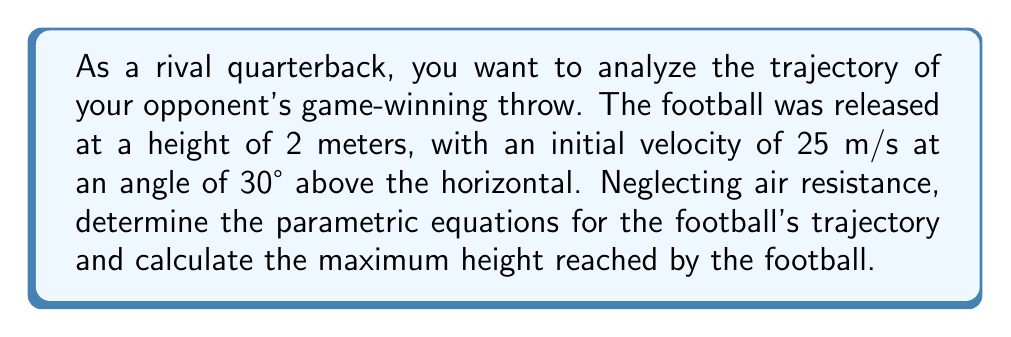Help me with this question. Let's approach this step-by-step:

1) First, we need to set up our parametric equations. In general, for a projectile motion, we have:

   $x(t) = x_0 + v_0 \cos(\theta) t$
   $y(t) = y_0 + v_0 \sin(\theta) t - \frac{1}{2}gt^2$

   Where:
   - $(x_0, y_0)$ is the initial position
   - $v_0$ is the initial velocity
   - $\theta$ is the angle of launch
   - $g$ is the acceleration due to gravity (9.8 m/s²)
   - $t$ is time

2) Given information:
   - $x_0 = 0$ (we can assume the initial horizontal position is 0)
   - $y_0 = 2$ meters
   - $v_0 = 25$ m/s
   - $\theta = 30°$

3) Let's substitute these values:

   $x(t) = 0 + 25 \cos(30°) t = 25 \cos(30°) t$
   $y(t) = 2 + 25 \sin(30°) t - \frac{1}{2}(9.8)t^2$

4) Simplify:
   $x(t) = 25 \cdot \frac{\sqrt{3}}{2} t \approx 21.65t$
   $y(t) = 2 + 25 \cdot \frac{1}{2} t - 4.9t^2 = 2 + 12.5t - 4.9t^2$

5) To find the maximum height, we need to find when the vertical velocity is zero:
   $\frac{dy}{dt} = 12.5 - 9.8t = 0$
   $t = \frac{12.5}{9.8} \approx 1.28$ seconds

6) Substitute this time back into the y(t) equation:
   $y_{max} = 2 + 12.5(1.28) - 4.9(1.28)^2$
   $y_{max} = 2 + 16 - 8 = 10$ meters

Therefore, the maximum height reached by the football is 10 meters.
Answer: The parametric equations for the football's trajectory are:
$x(t) \approx 21.65t$
$y(t) = 2 + 12.5t - 4.9t^2$

The maximum height reached by the football is 10 meters. 